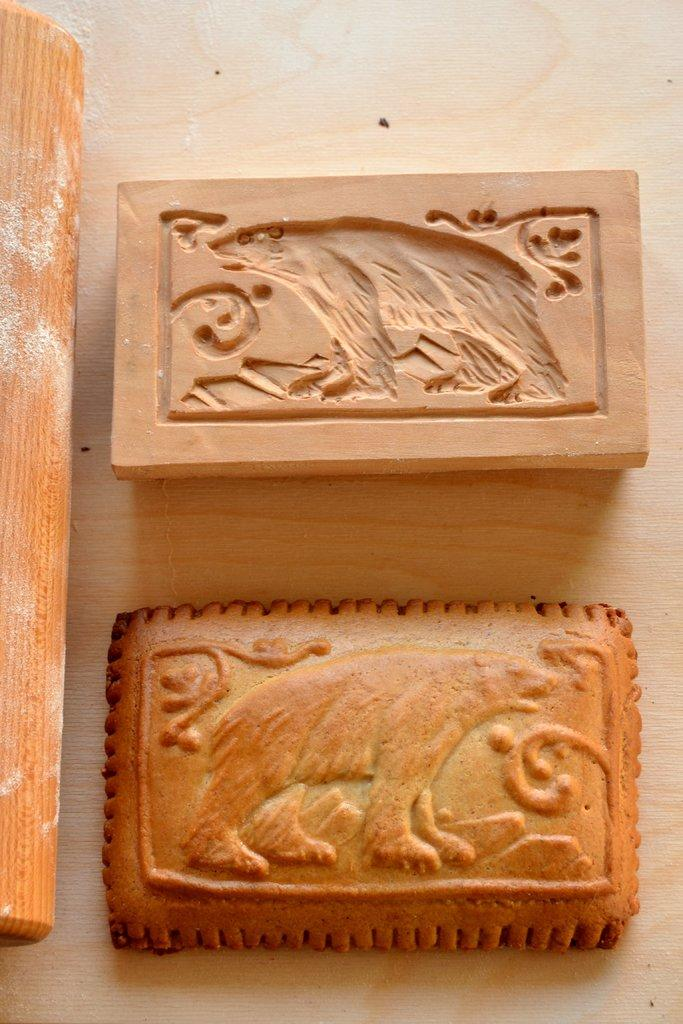What type of surface is visible in the image? There is a wooden surface in the image. What is on the wooden surface? There is a mould on the wooden surface. What else can be seen beside the mould on the wooden surface? There is a wooden object beside the mould. What might be the purpose of the object that looks like a biscuit in the image? The object that looks like a biscuit might be a baked good or a decorative item. What type of instrument is being played by the crowd in the image? There is no crowd or instrument present in the image; it features a wooden surface with a mould and a wooden object beside it. 